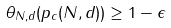<formula> <loc_0><loc_0><loc_500><loc_500>\theta _ { N , d } ( p _ { c } ( N , d ) ) \geq 1 - \epsilon</formula> 